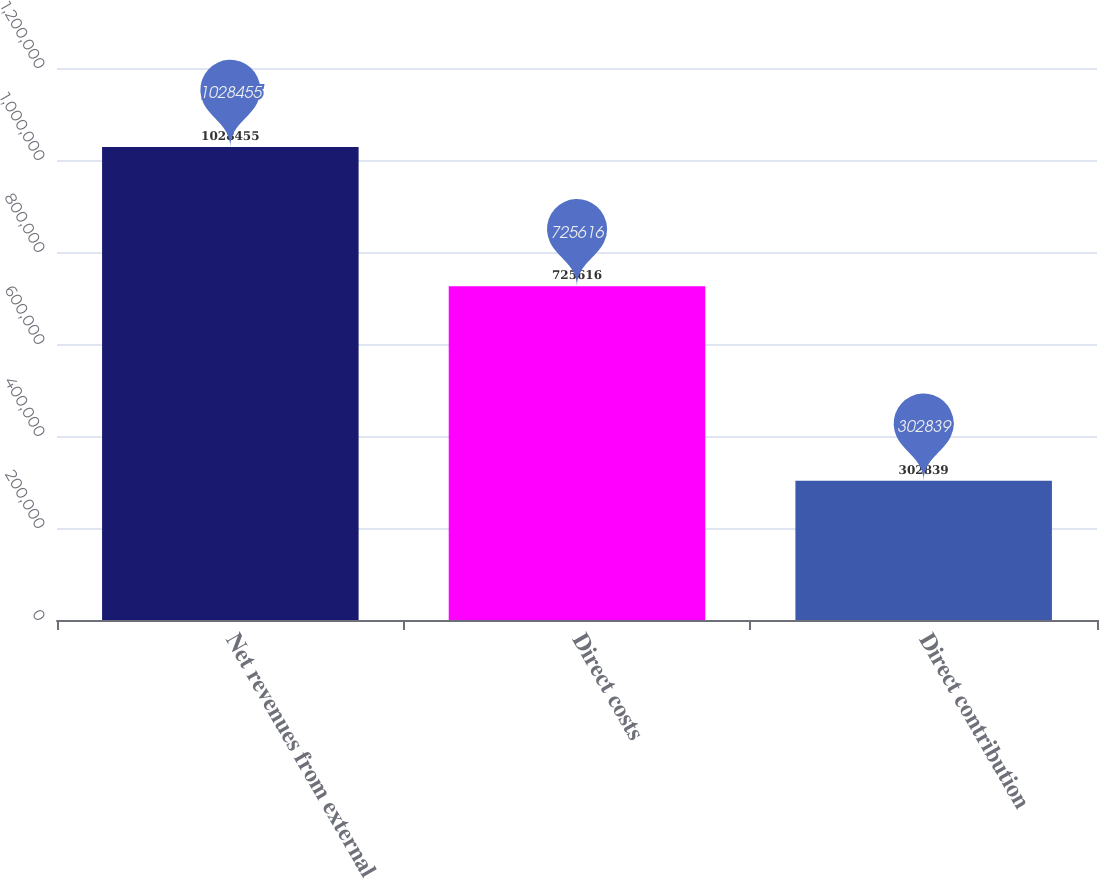Convert chart. <chart><loc_0><loc_0><loc_500><loc_500><bar_chart><fcel>Net revenues from external<fcel>Direct costs<fcel>Direct contribution<nl><fcel>1.02846e+06<fcel>725616<fcel>302839<nl></chart> 